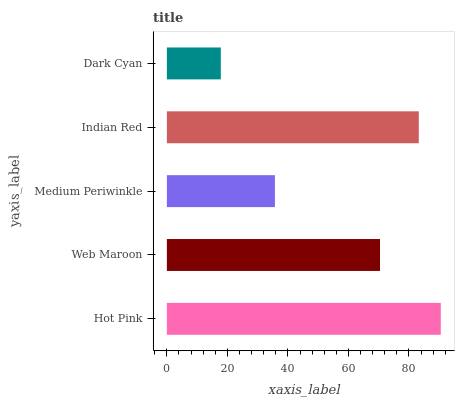Is Dark Cyan the minimum?
Answer yes or no. Yes. Is Hot Pink the maximum?
Answer yes or no. Yes. Is Web Maroon the minimum?
Answer yes or no. No. Is Web Maroon the maximum?
Answer yes or no. No. Is Hot Pink greater than Web Maroon?
Answer yes or no. Yes. Is Web Maroon less than Hot Pink?
Answer yes or no. Yes. Is Web Maroon greater than Hot Pink?
Answer yes or no. No. Is Hot Pink less than Web Maroon?
Answer yes or no. No. Is Web Maroon the high median?
Answer yes or no. Yes. Is Web Maroon the low median?
Answer yes or no. Yes. Is Hot Pink the high median?
Answer yes or no. No. Is Dark Cyan the low median?
Answer yes or no. No. 